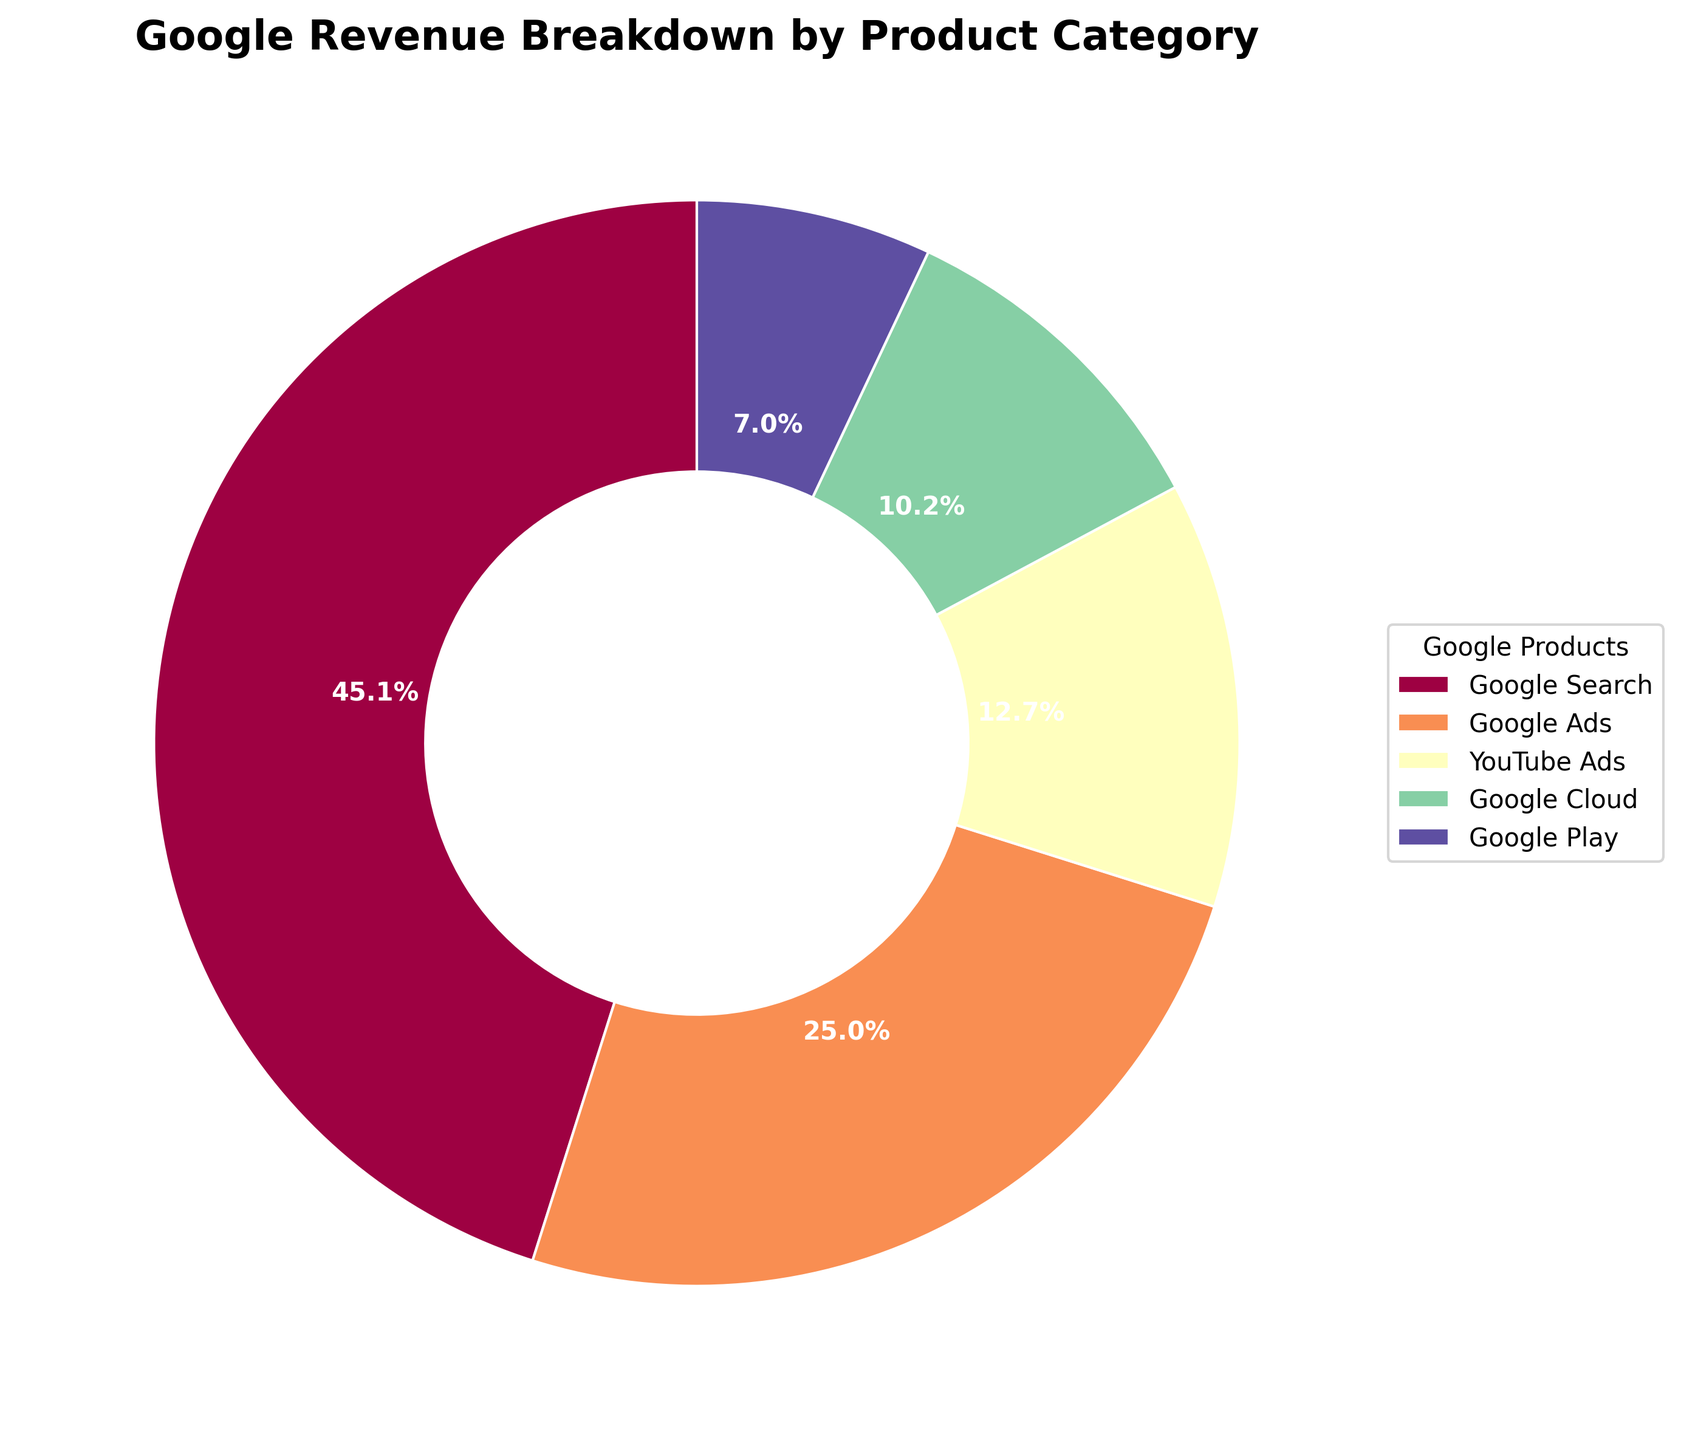What percentage of Google's revenue comes from Google Search? The figure uses a pie chart to represent the percentage of revenue from each product category. The slice labeled "Google Search" shows a percentage.
Answer: 47.3% Which product contributes the least to Google's revenue? The smallest slice in the pie chart corresponds to the product that generates the least revenue. This slice is labeled "Google Play."
Answer: Google Play Is the combined revenue of Google Ads and YouTube Ads greater than that of Google Search? Sum the percentages of Google Ads and YouTube Ads and compare it with the percentage of Google Search. Google Ads is 26.3% and YouTube Ads is 13.3%, totaling 39.6%, while Google Search is 47.3%.
Answer: No How does the revenue from Google Cloud compare to that from Google Ads? Compare the size of the slices representing Google Cloud and Google Ads. Google Cloud's slice is smaller than Google Ads'.
Answer: Google Ads is greater What's the combined share of revenue from YouTube Ads and Google Cloud? Sum the percentages from the pie chart for YouTube Ads and Google Cloud. YouTube Ads is 13.3% and Google Cloud is 10.7%, resulting in the total percentage.
Answer: 24% What is the difference in revenue percentage between Google Search and Google Cloud? Subtract the percentage of Google Cloud's slice from Google's Search slice in the pie chart. Google Search is 47.3% and Google Cloud is 10.7%.
Answer: 36.6% Which product category has a revenue share closest to 25%? Identify which slice has a percentage closest to 25% by examining the pie chart. Google Ads has a revenue share of 26.3%, which is the closest to 25%.
Answer: Google Ads If you sum the revenue percentages of Google Play and YouTube Ads, do they surpass Google Ads? Add the pie chart percentages for Google Play and YouTube Ads. Google Play is 7.4% and YouTube Ads is 13.3%, resulting in 20.7%, which is less than Google Ads' 26.3%.
Answer: No What color represents Google Search in the chart? Identify the color of the slice labeled "Google Search" in the pie chart. In this case, Google Search is a certain color since it is the largest slice.
Answer: not specified What's the percentage difference between the revenues of Google Play and YouTube Ads? Subtract the percentage of Google Play from the percentage of YouTube Ads. YouTube Ads is 13.3% and Google Play is 7.4%.
Answer: 5.9% 